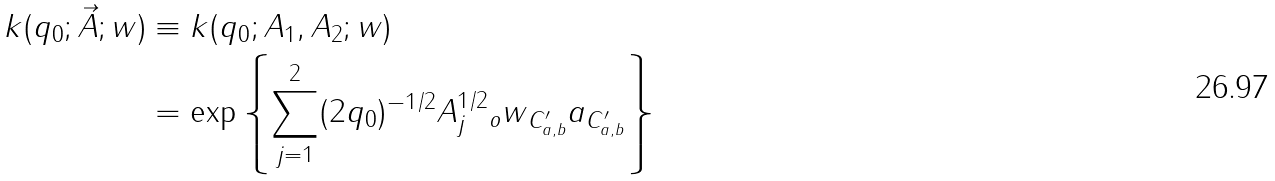<formula> <loc_0><loc_0><loc_500><loc_500>k ( q _ { 0 } ; \vec { A } ; w ) & \equiv k ( q _ { 0 } ; A _ { 1 } , A _ { 2 } ; w ) \\ & = \exp \left \{ \sum _ { j = 1 } ^ { 2 } ( 2 q _ { 0 } ) ^ { - 1 / 2 } \| A _ { j } ^ { 1 / 2 } \| _ { o } \| w \| _ { C _ { a , b } ^ { \prime } } \| a \| _ { C _ { a , b } ^ { \prime } } \right \}</formula> 